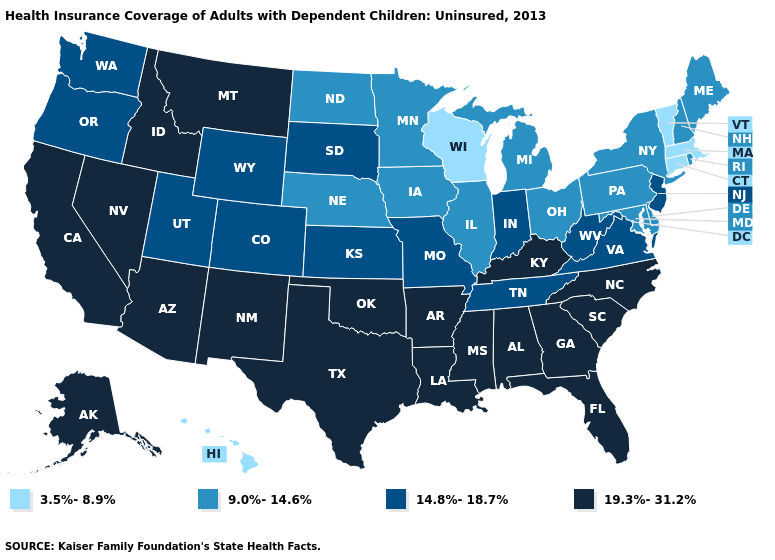Name the states that have a value in the range 14.8%-18.7%?
Give a very brief answer. Colorado, Indiana, Kansas, Missouri, New Jersey, Oregon, South Dakota, Tennessee, Utah, Virginia, Washington, West Virginia, Wyoming. Does Virginia have a higher value than Kansas?
Short answer required. No. What is the lowest value in the South?
Answer briefly. 9.0%-14.6%. What is the lowest value in the USA?
Write a very short answer. 3.5%-8.9%. What is the lowest value in the USA?
Write a very short answer. 3.5%-8.9%. Among the states that border Ohio , does Indiana have the lowest value?
Be succinct. No. Among the states that border Connecticut , which have the lowest value?
Answer briefly. Massachusetts. Name the states that have a value in the range 19.3%-31.2%?
Concise answer only. Alabama, Alaska, Arizona, Arkansas, California, Florida, Georgia, Idaho, Kentucky, Louisiana, Mississippi, Montana, Nevada, New Mexico, North Carolina, Oklahoma, South Carolina, Texas. What is the lowest value in the USA?
Give a very brief answer. 3.5%-8.9%. How many symbols are there in the legend?
Give a very brief answer. 4. Name the states that have a value in the range 9.0%-14.6%?
Concise answer only. Delaware, Illinois, Iowa, Maine, Maryland, Michigan, Minnesota, Nebraska, New Hampshire, New York, North Dakota, Ohio, Pennsylvania, Rhode Island. What is the value of Hawaii?
Quick response, please. 3.5%-8.9%. Name the states that have a value in the range 3.5%-8.9%?
Short answer required. Connecticut, Hawaii, Massachusetts, Vermont, Wisconsin. Does the first symbol in the legend represent the smallest category?
Give a very brief answer. Yes. Does Kentucky have the lowest value in the USA?
Write a very short answer. No. 